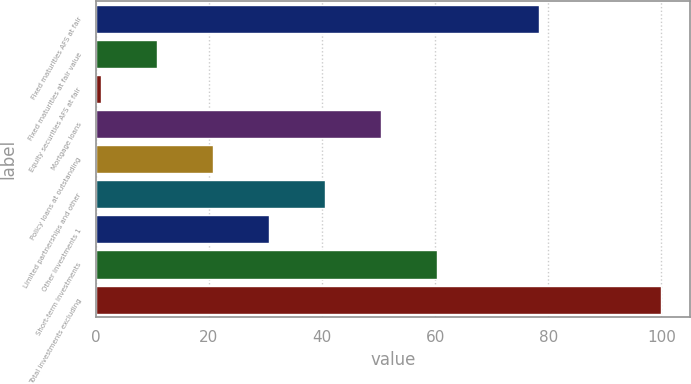Convert chart. <chart><loc_0><loc_0><loc_500><loc_500><bar_chart><fcel>Fixed maturities AFS at fair<fcel>Fixed maturities at fair value<fcel>Equity securities AFS at fair<fcel>Mortgage loans<fcel>Policy loans at outstanding<fcel>Limited partnerships and other<fcel>Other investments 1<fcel>Short-term investments<fcel>Total investments excluding<nl><fcel>78.3<fcel>10.81<fcel>0.9<fcel>50.45<fcel>20.72<fcel>40.54<fcel>30.63<fcel>60.36<fcel>100<nl></chart> 